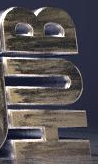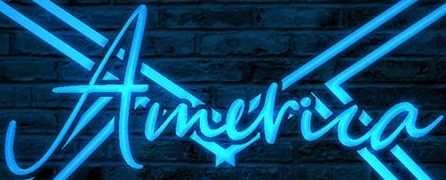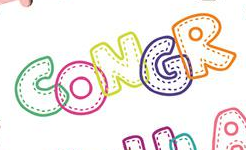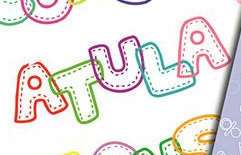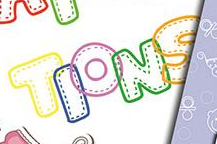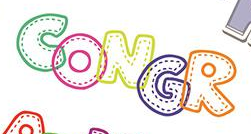Read the text content from these images in order, separated by a semicolon. HUB; America; CONGR; ATULA; TIONS; CONGR 